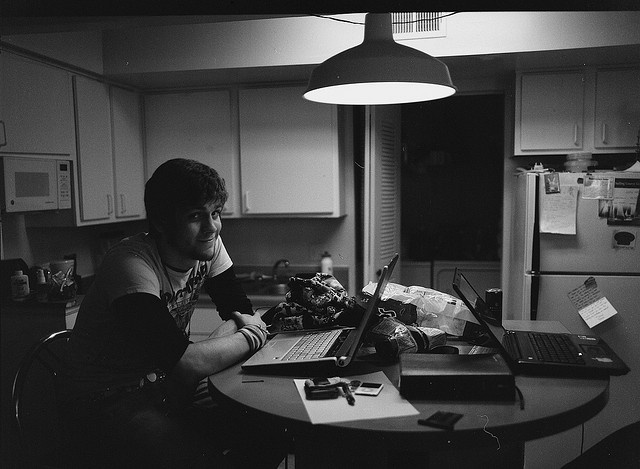Describe the objects in this image and their specific colors. I can see dining table in black, gray, darkgray, and lightgray tones, people in black, gray, and lightgray tones, refrigerator in black, gray, darkgray, and lightgray tones, laptop in black, gray, and lightgray tones, and book in black and gray tones in this image. 